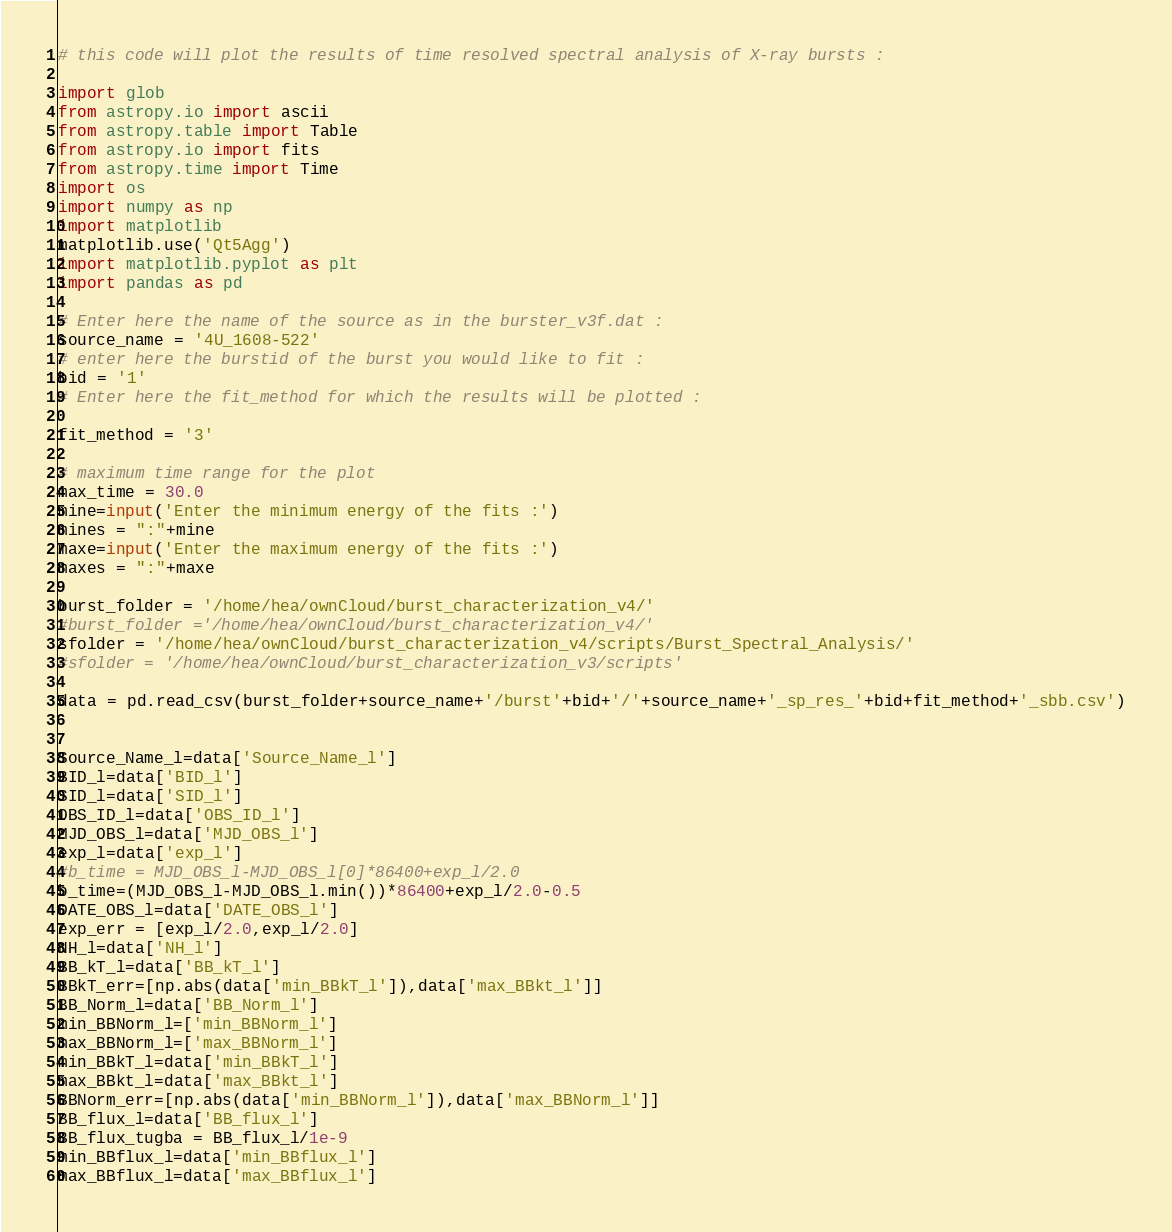<code> <loc_0><loc_0><loc_500><loc_500><_Python_># this code will plot the results of time resolved spectral analysis of X-ray bursts :

import glob
from astropy.io import ascii
from astropy.table import Table
from astropy.io import fits
from astropy.time import Time
import os
import numpy as np
import matplotlib
matplotlib.use('Qt5Agg')
import matplotlib.pyplot as plt
import pandas as pd

# Enter here the name of the source as in the burster_v3f.dat : 
source_name = '4U_1608-522'
# enter here the burstid of the burst you would like to fit :
bid = '1'
# Enter here the fit_method for which the results will be plotted :

fit_method = '3'

# maximum time range for the plot
max_time = 30.0
mine=input('Enter the minimum energy of the fits :')
mines = ":"+mine
maxe=input('Enter the maximum energy of the fits :')
maxes = ":"+maxe

burst_folder = '/home/hea/ownCloud/burst_characterization_v4/'
#burst_folder ='/home/hea/ownCloud/burst_characterization_v4/'
sfolder = '/home/hea/ownCloud/burst_characterization_v4/scripts/Burst_Spectral_Analysis/'
#sfolder = '/home/hea/ownCloud/burst_characterization_v3/scripts'

data = pd.read_csv(burst_folder+source_name+'/burst'+bid+'/'+source_name+'_sp_res_'+bid+fit_method+'_sbb.csv')


Source_Name_l=data['Source_Name_l']
BID_l=data['BID_l']
SID_l=data['SID_l']
OBS_ID_l=data['OBS_ID_l']
MJD_OBS_l=data['MJD_OBS_l']
exp_l=data['exp_l']
#b_time = MJD_OBS_l-MJD_OBS_l[0]*86400+exp_l/2.0
b_time=(MJD_OBS_l-MJD_OBS_l.min())*86400+exp_l/2.0-0.5
DATE_OBS_l=data['DATE_OBS_l']
exp_err = [exp_l/2.0,exp_l/2.0]
NH_l=data['NH_l']
BB_kT_l=data['BB_kT_l']
BBkT_err=[np.abs(data['min_BBkT_l']),data['max_BBkt_l']]
BB_Norm_l=data['BB_Norm_l']
min_BBNorm_l=['min_BBNorm_l']
max_BBNorm_l=['max_BBNorm_l']
min_BBkT_l=data['min_BBkT_l']
max_BBkt_l=data['max_BBkt_l']
BBNorm_err=[np.abs(data['min_BBNorm_l']),data['max_BBNorm_l']]
BB_flux_l=data['BB_flux_l']
BB_flux_tugba = BB_flux_l/1e-9
min_BBflux_l=data['min_BBflux_l']
max_BBflux_l=data['max_BBflux_l']</code> 